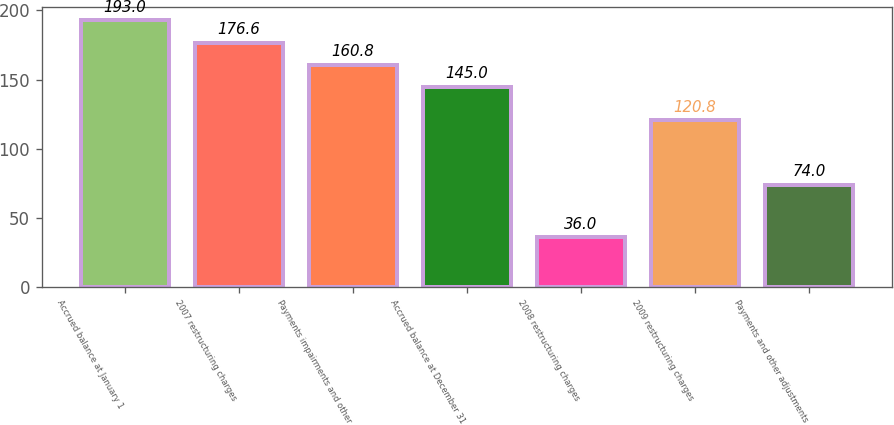Convert chart to OTSL. <chart><loc_0><loc_0><loc_500><loc_500><bar_chart><fcel>Accrued balance at January 1<fcel>2007 restructuring charges<fcel>Payments impairments and other<fcel>Accrued balance at December 31<fcel>2008 restructuring charges<fcel>2009 restructuring charges<fcel>Payments and other adjustments<nl><fcel>193<fcel>176.6<fcel>160.8<fcel>145<fcel>36<fcel>120.8<fcel>74<nl></chart> 